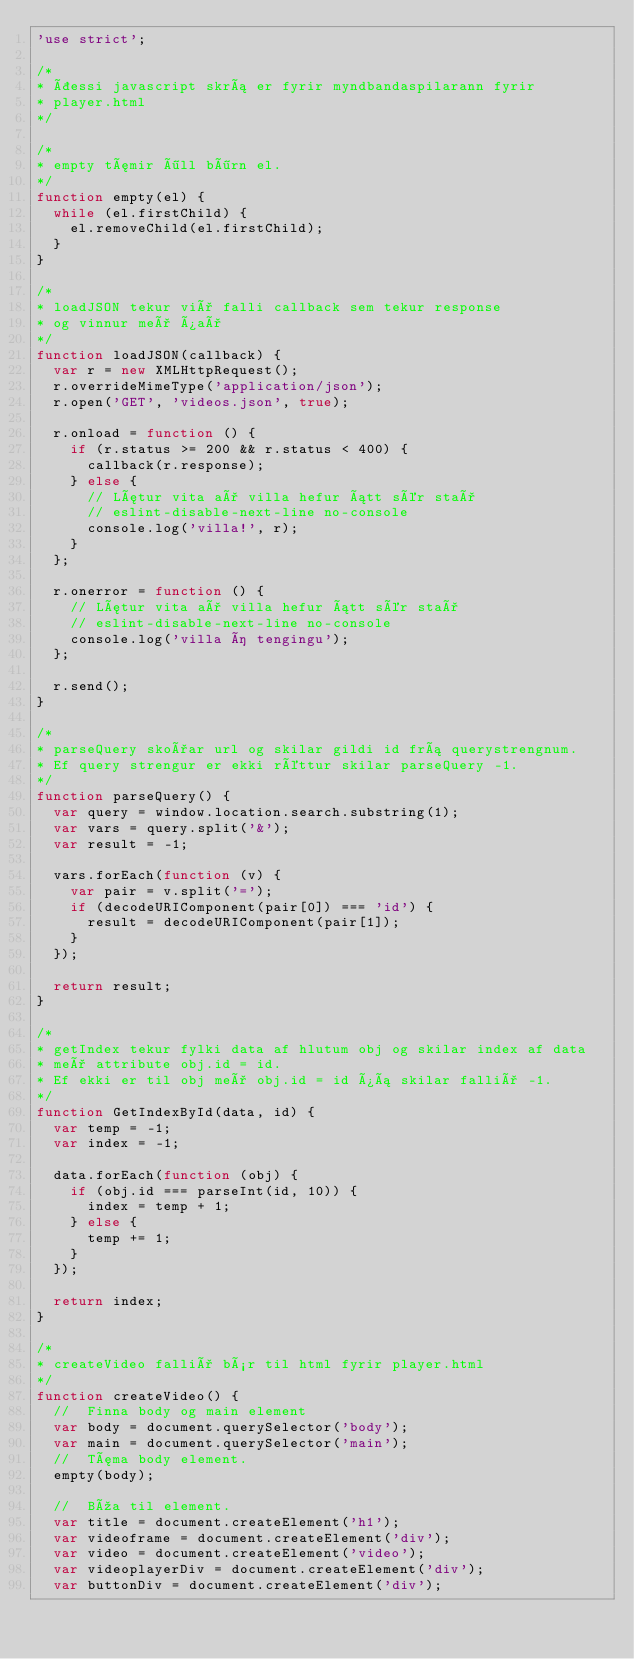Convert code to text. <code><loc_0><loc_0><loc_500><loc_500><_JavaScript_>'use strict';

/*
* Þessi javascript skrá er fyrir myndbandaspilarann fyrir
* player.html
*/

/*
* empty tæmir öll börn el.
*/
function empty(el) {
  while (el.firstChild) {
    el.removeChild(el.firstChild);
  }
}

/*
* loadJSON tekur við falli callback sem tekur response
* og vinnur með það
*/
function loadJSON(callback) {
  var r = new XMLHttpRequest();
  r.overrideMimeType('application/json');
  r.open('GET', 'videos.json', true);

  r.onload = function () {
    if (r.status >= 200 && r.status < 400) {
      callback(r.response);
    } else {
      // Lætur vita að villa hefur átt sér stað
      // eslint-disable-next-line no-console
      console.log('villa!', r);
    }
  };

  r.onerror = function () {
    // Lætur vita að villa hefur átt sér stað
    // eslint-disable-next-line no-console
    console.log('villa í tengingu');
  };

  r.send();
}

/*
* parseQuery skoðar url og skilar gildi id frá querystrengnum.
* Ef query strengur er ekki réttur skilar parseQuery -1.
*/
function parseQuery() {
  var query = window.location.search.substring(1);
  var vars = query.split('&');
  var result = -1;

  vars.forEach(function (v) {
    var pair = v.split('=');
    if (decodeURIComponent(pair[0]) === 'id') {
      result = decodeURIComponent(pair[1]);
    }
  });

  return result;
}

/*
* getIndex tekur fylki data af hlutum obj og skilar index af data
* með attribute obj.id = id.
* Ef ekki er til obj með obj.id = id þá skilar fallið -1.
*/
function GetIndexById(data, id) {
  var temp = -1;
  var index = -1;

  data.forEach(function (obj) {
    if (obj.id === parseInt(id, 10)) {
      index = temp + 1;
    } else {
      temp += 1;
    }
  });

  return index;
}

/*
* createVideo fallið býr til html fyrir player.html
*/
function createVideo() {
  //  Finna body og main element
  var body = document.querySelector('body');
  var main = document.querySelector('main');
  //  Tæma body element.
  empty(body);

  //  Búa til element.
  var title = document.createElement('h1');
  var videoframe = document.createElement('div');
  var video = document.createElement('video');
  var videoplayerDiv = document.createElement('div');
  var buttonDiv = document.createElement('div');</code> 